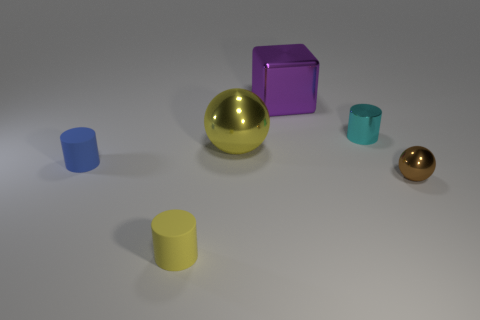Subtract all tiny matte cylinders. How many cylinders are left? 1 Add 1 large cylinders. How many objects exist? 7 Subtract all cubes. How many objects are left? 5 Subtract all brown cylinders. Subtract all red balls. How many cylinders are left? 3 Add 5 small gray metal cubes. How many small gray metal cubes exist? 5 Subtract 0 red spheres. How many objects are left? 6 Subtract all small yellow rubber cylinders. Subtract all big balls. How many objects are left? 4 Add 6 purple things. How many purple things are left? 7 